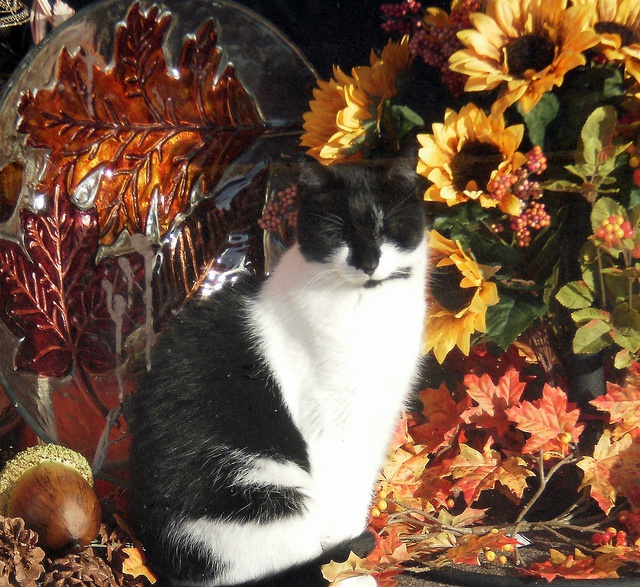Describe the objects in this image and their specific colors. I can see a cat in black, white, gray, and darkgray tones in this image. 